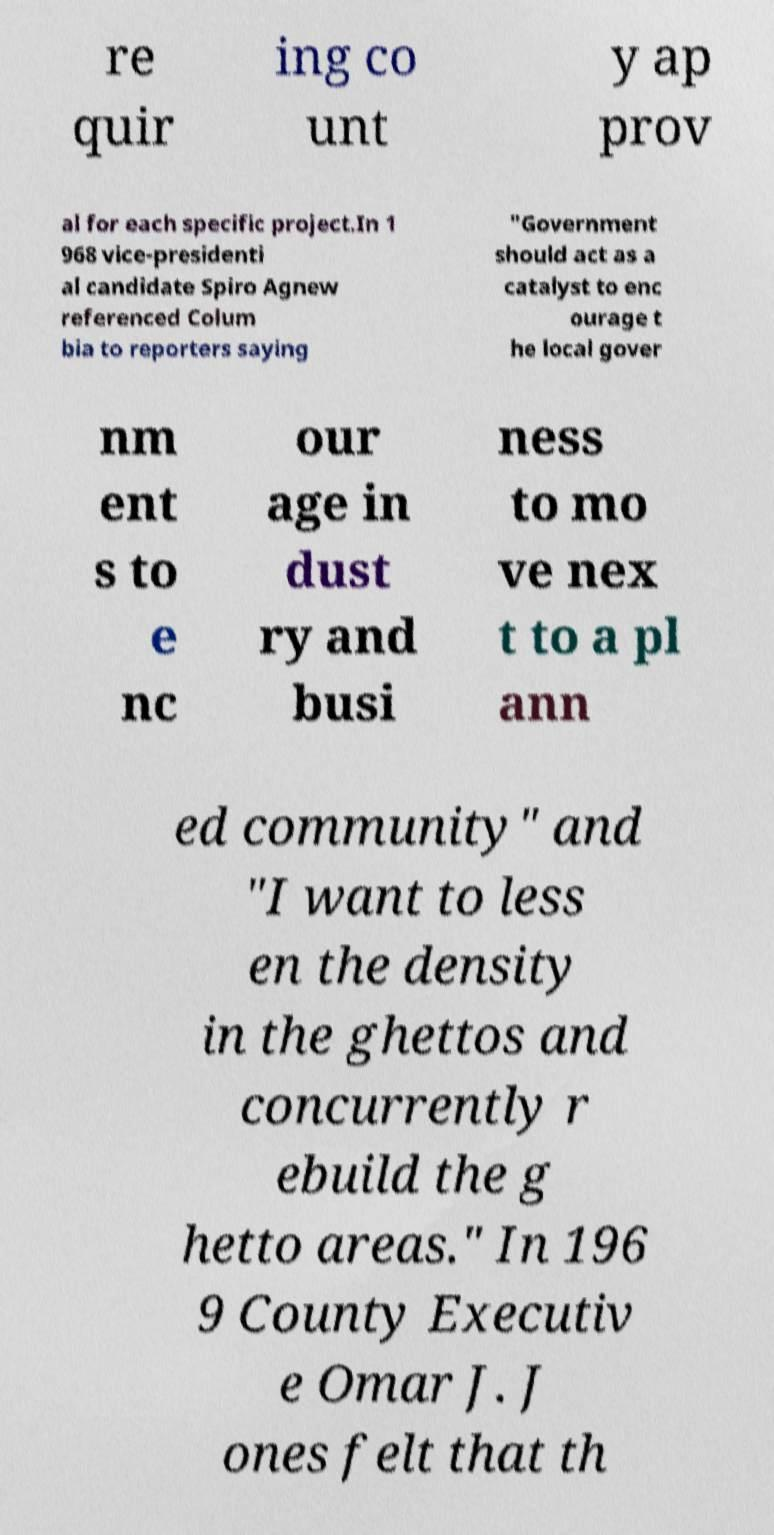I need the written content from this picture converted into text. Can you do that? re quir ing co unt y ap prov al for each specific project.In 1 968 vice-presidenti al candidate Spiro Agnew referenced Colum bia to reporters saying "Government should act as a catalyst to enc ourage t he local gover nm ent s to e nc our age in dust ry and busi ness to mo ve nex t to a pl ann ed community" and "I want to less en the density in the ghettos and concurrently r ebuild the g hetto areas." In 196 9 County Executiv e Omar J. J ones felt that th 